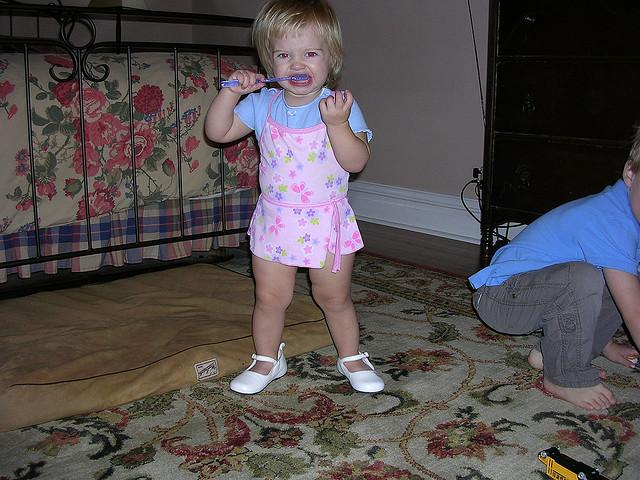Why are her eyes red? camera flash 